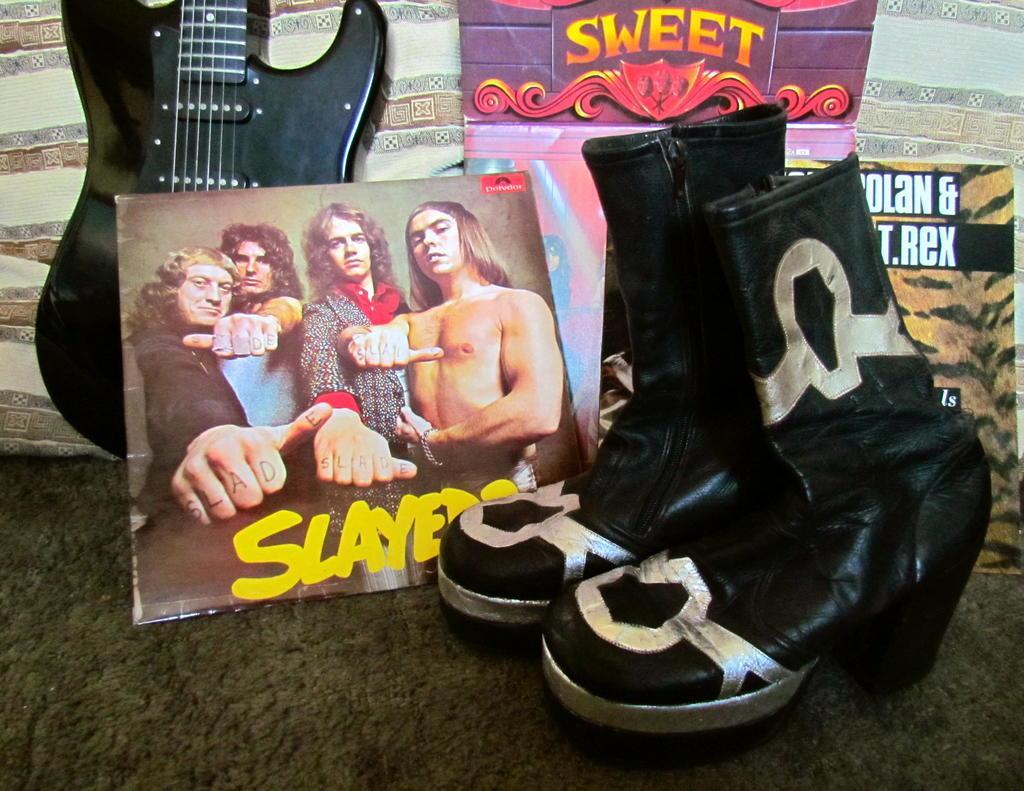In one or two sentences, can you explain what this image depicts? In this image there is a guitar to the wall and there is a shoe beside it. There is a poster in between both the shoe and the guitar. 